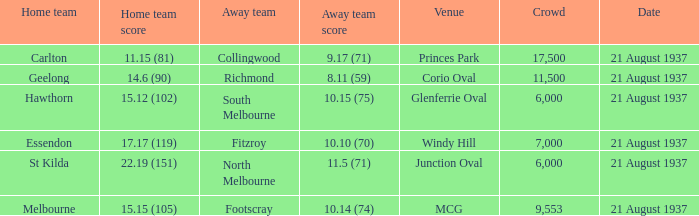Where did Richmond play? Corio Oval. 